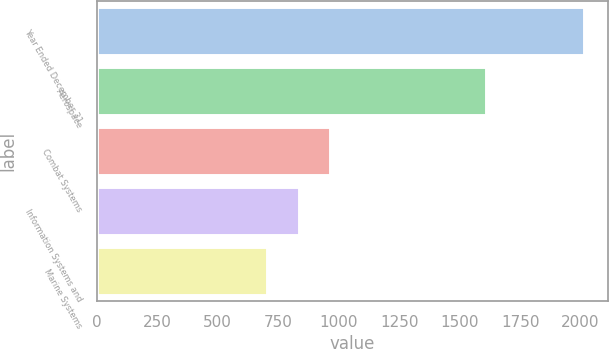Convert chart to OTSL. <chart><loc_0><loc_0><loc_500><loc_500><bar_chart><fcel>Year Ended December 31<fcel>Aerospace<fcel>Combat Systems<fcel>Information Systems and<fcel>Marine Systems<nl><fcel>2014<fcel>1611<fcel>965.2<fcel>834.1<fcel>703<nl></chart> 